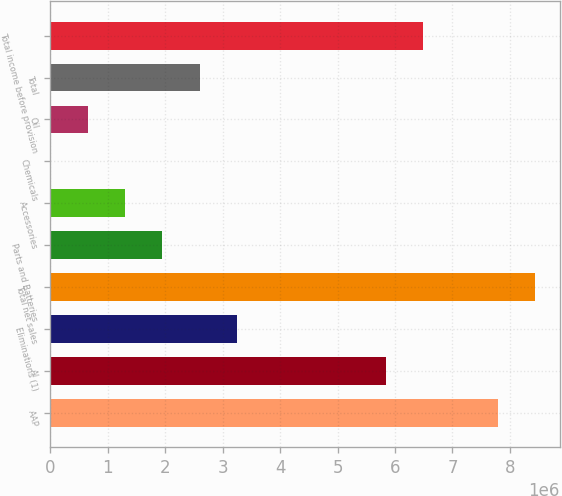<chart> <loc_0><loc_0><loc_500><loc_500><bar_chart><fcel>AAP<fcel>AI<fcel>Eliminations (1)<fcel>Total net sales<fcel>Parts and Batteries<fcel>Accessories<fcel>Chemicals<fcel>Oil<fcel>Total<fcel>Total income before provision<nl><fcel>7.79257e+06<fcel>5.84443e+06<fcel>3.24691e+06<fcel>8.44196e+06<fcel>1.94815e+06<fcel>1.29877e+06<fcel>10<fcel>649390<fcel>2.59753e+06<fcel>6.49381e+06<nl></chart> 